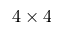Convert formula to latex. <formula><loc_0><loc_0><loc_500><loc_500>4 \times 4</formula> 